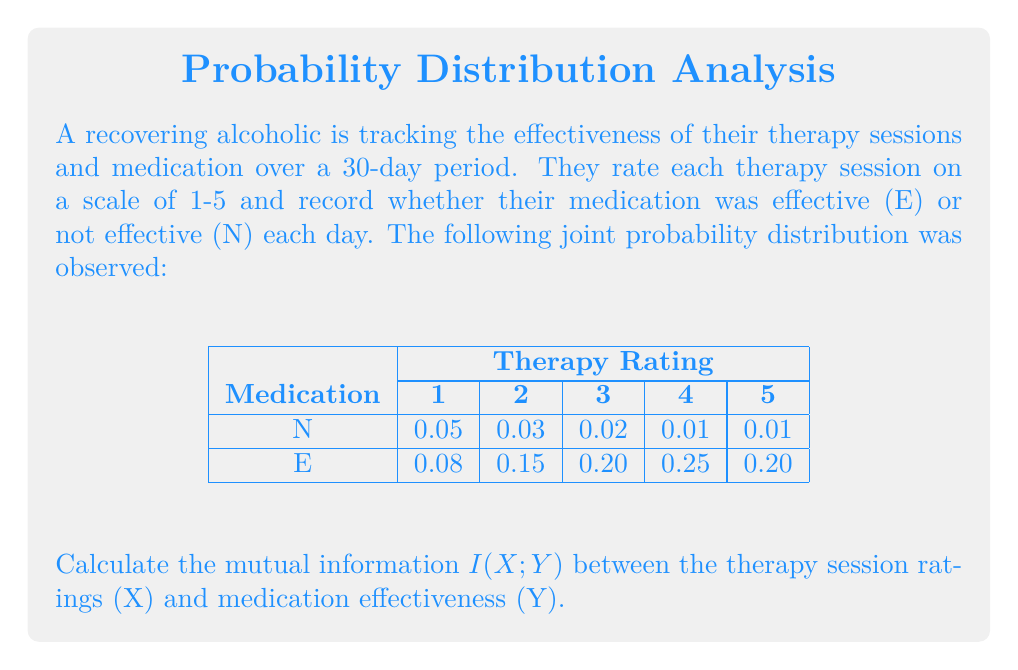Can you answer this question? To calculate the mutual information $I(X;Y)$, we'll follow these steps:

1) First, we need to calculate the marginal probabilities:

   P(X=1) = 0.05 + 0.08 = 0.13
   P(X=2) = 0.03 + 0.15 = 0.18
   P(X=3) = 0.02 + 0.20 = 0.22
   P(X=4) = 0.01 + 0.25 = 0.26
   P(X=5) = 0.01 + 0.20 = 0.21

   P(Y=N) = 0.05 + 0.03 + 0.02 + 0.01 + 0.01 = 0.12
   P(Y=E) = 0.08 + 0.15 + 0.20 + 0.25 + 0.20 = 0.88

2) The mutual information is defined as:

   $$I(X;Y) = \sum_{x \in X} \sum_{y \in Y} P(x,y) \log_2 \frac{P(x,y)}{P(x)P(y)}$$

3) Let's calculate each term:

   For X=1, Y=N: 0.05 * log2(0.05 / (0.13 * 0.12)) = 0.0722
   For X=2, Y=N: 0.03 * log2(0.03 / (0.18 * 0.12)) = 0.0288
   For X=3, Y=N: 0.02 * log2(0.02 / (0.22 * 0.12)) = 0.0112
   For X=4, Y=N: 0.01 * log2(0.01 / (0.26 * 0.12)) = 0.0026
   For X=5, Y=N: 0.01 * log2(0.01 / (0.21 * 0.12)) = 0.0038

   For X=1, Y=E: 0.08 * log2(0.08 / (0.13 * 0.88)) = -0.0203
   For X=2, Y=E: 0.15 * log2(0.15 / (0.18 * 0.88)) = 0.0066
   For X=3, Y=E: 0.20 * log2(0.20 / (0.22 * 0.88)) = 0.0160
   For X=4, Y=E: 0.25 * log2(0.25 / (0.26 * 0.88)) = 0.0305
   For X=5, Y=E: 0.20 * log2(0.20 / (0.21 * 0.88)) = 0.0221

4) Sum all these terms:

   I(X;Y) = 0.0722 + 0.0288 + 0.0112 + 0.0026 + 0.0038 - 0.0203 + 0.0066 + 0.0160 + 0.0305 + 0.0221 = 0.1735 bits
Answer: 0.1735 bits 